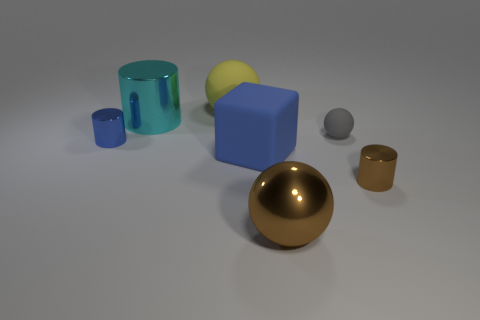Subtract all large balls. How many balls are left? 1 Subtract 1 cylinders. How many cylinders are left? 2 Add 3 large blue things. How many objects exist? 10 Subtract all green cylinders. Subtract all cyan balls. How many cylinders are left? 3 Subtract 1 brown cylinders. How many objects are left? 6 Subtract all blocks. How many objects are left? 6 Subtract all big blue cubes. Subtract all large shiny balls. How many objects are left? 5 Add 1 big yellow objects. How many big yellow objects are left? 2 Add 5 cyan objects. How many cyan objects exist? 6 